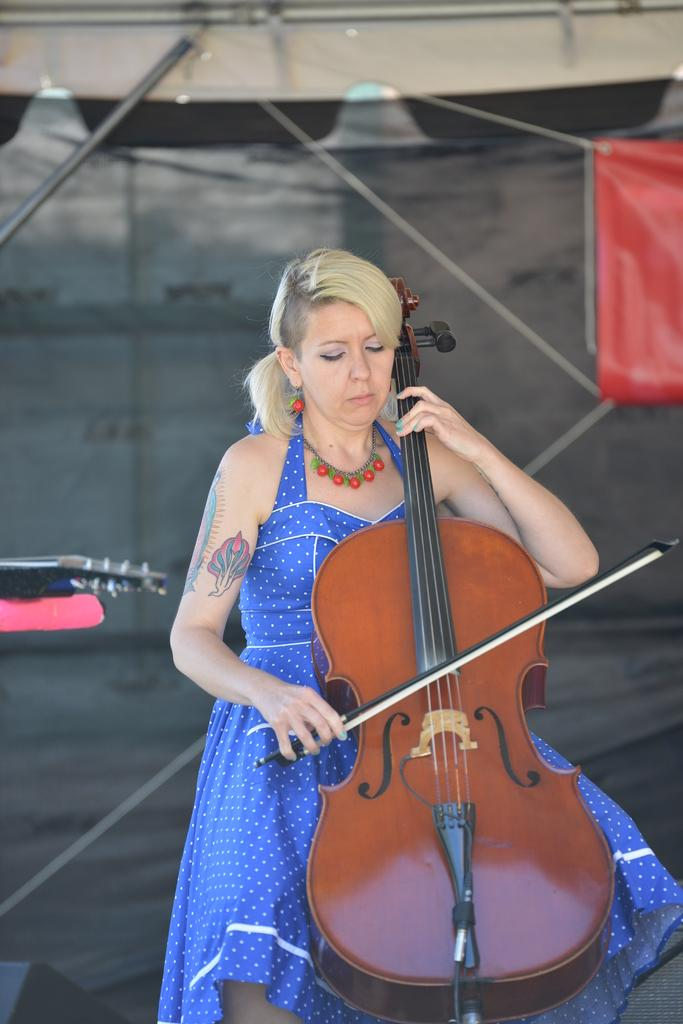What is the main subject of the image? The main subject of the image is women. What are the women in the image doing? The women are playing a musical instrument. Can you see any goldfish swimming in the image? There are no goldfish present in the image. What type of cap is the woman wearing in the image? There is no cap visible in the image, as the women are playing a musical instrument and no such accessory is mentioned or shown. 